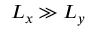Convert formula to latex. <formula><loc_0><loc_0><loc_500><loc_500>L _ { x } \gg L _ { y }</formula> 